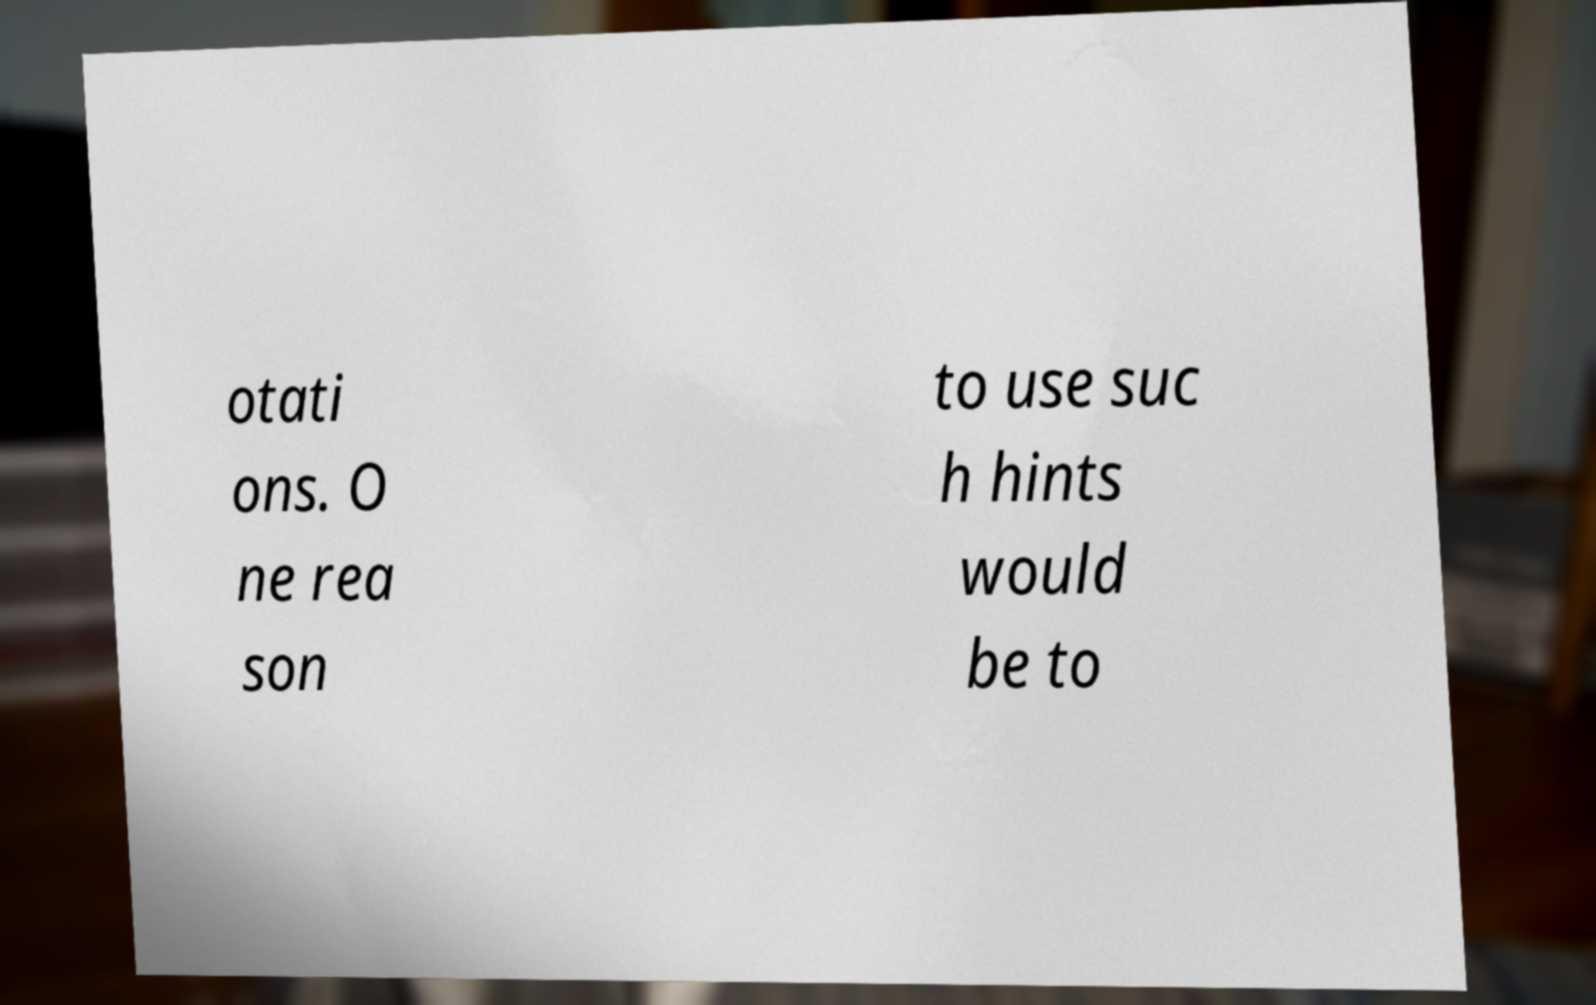There's text embedded in this image that I need extracted. Can you transcribe it verbatim? otati ons. O ne rea son to use suc h hints would be to 